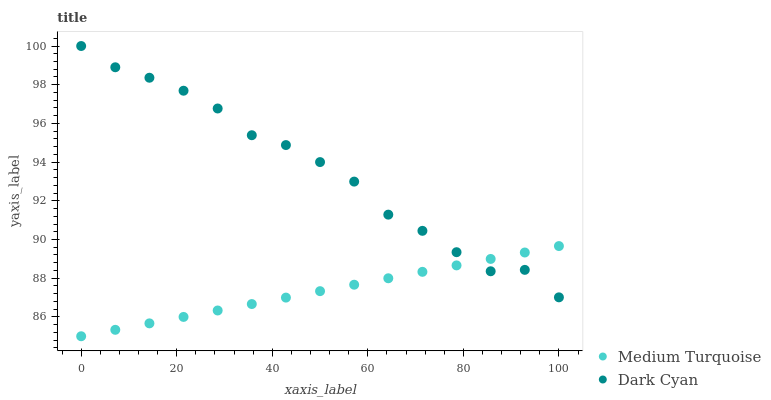Does Medium Turquoise have the minimum area under the curve?
Answer yes or no. Yes. Does Dark Cyan have the maximum area under the curve?
Answer yes or no. Yes. Does Medium Turquoise have the maximum area under the curve?
Answer yes or no. No. Is Medium Turquoise the smoothest?
Answer yes or no. Yes. Is Dark Cyan the roughest?
Answer yes or no. Yes. Is Medium Turquoise the roughest?
Answer yes or no. No. Does Medium Turquoise have the lowest value?
Answer yes or no. Yes. Does Dark Cyan have the highest value?
Answer yes or no. Yes. Does Medium Turquoise have the highest value?
Answer yes or no. No. Does Dark Cyan intersect Medium Turquoise?
Answer yes or no. Yes. Is Dark Cyan less than Medium Turquoise?
Answer yes or no. No. Is Dark Cyan greater than Medium Turquoise?
Answer yes or no. No. 